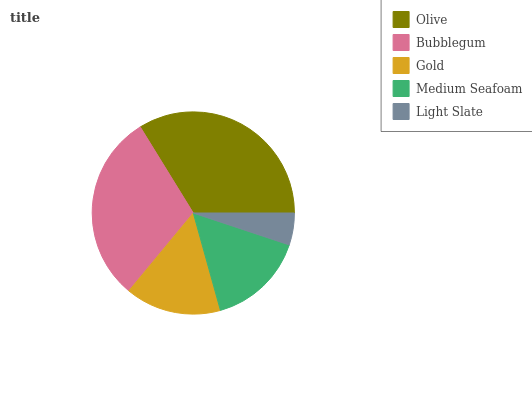Is Light Slate the minimum?
Answer yes or no. Yes. Is Olive the maximum?
Answer yes or no. Yes. Is Bubblegum the minimum?
Answer yes or no. No. Is Bubblegum the maximum?
Answer yes or no. No. Is Olive greater than Bubblegum?
Answer yes or no. Yes. Is Bubblegum less than Olive?
Answer yes or no. Yes. Is Bubblegum greater than Olive?
Answer yes or no. No. Is Olive less than Bubblegum?
Answer yes or no. No. Is Medium Seafoam the high median?
Answer yes or no. Yes. Is Medium Seafoam the low median?
Answer yes or no. Yes. Is Bubblegum the high median?
Answer yes or no. No. Is Gold the low median?
Answer yes or no. No. 